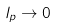<formula> <loc_0><loc_0><loc_500><loc_500>l _ { p } \rightarrow 0</formula> 